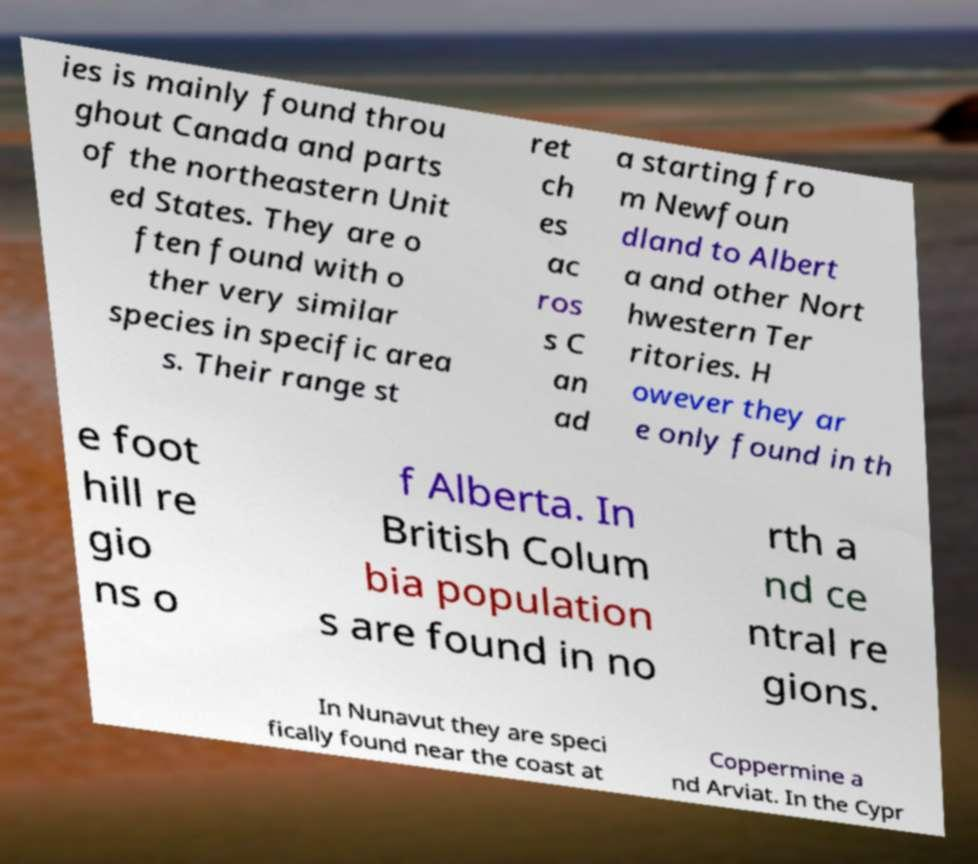Please read and relay the text visible in this image. What does it say? ies is mainly found throu ghout Canada and parts of the northeastern Unit ed States. They are o ften found with o ther very similar species in specific area s. Their range st ret ch es ac ros s C an ad a starting fro m Newfoun dland to Albert a and other Nort hwestern Ter ritories. H owever they ar e only found in th e foot hill re gio ns o f Alberta. In British Colum bia population s are found in no rth a nd ce ntral re gions. In Nunavut they are speci fically found near the coast at Coppermine a nd Arviat. In the Cypr 